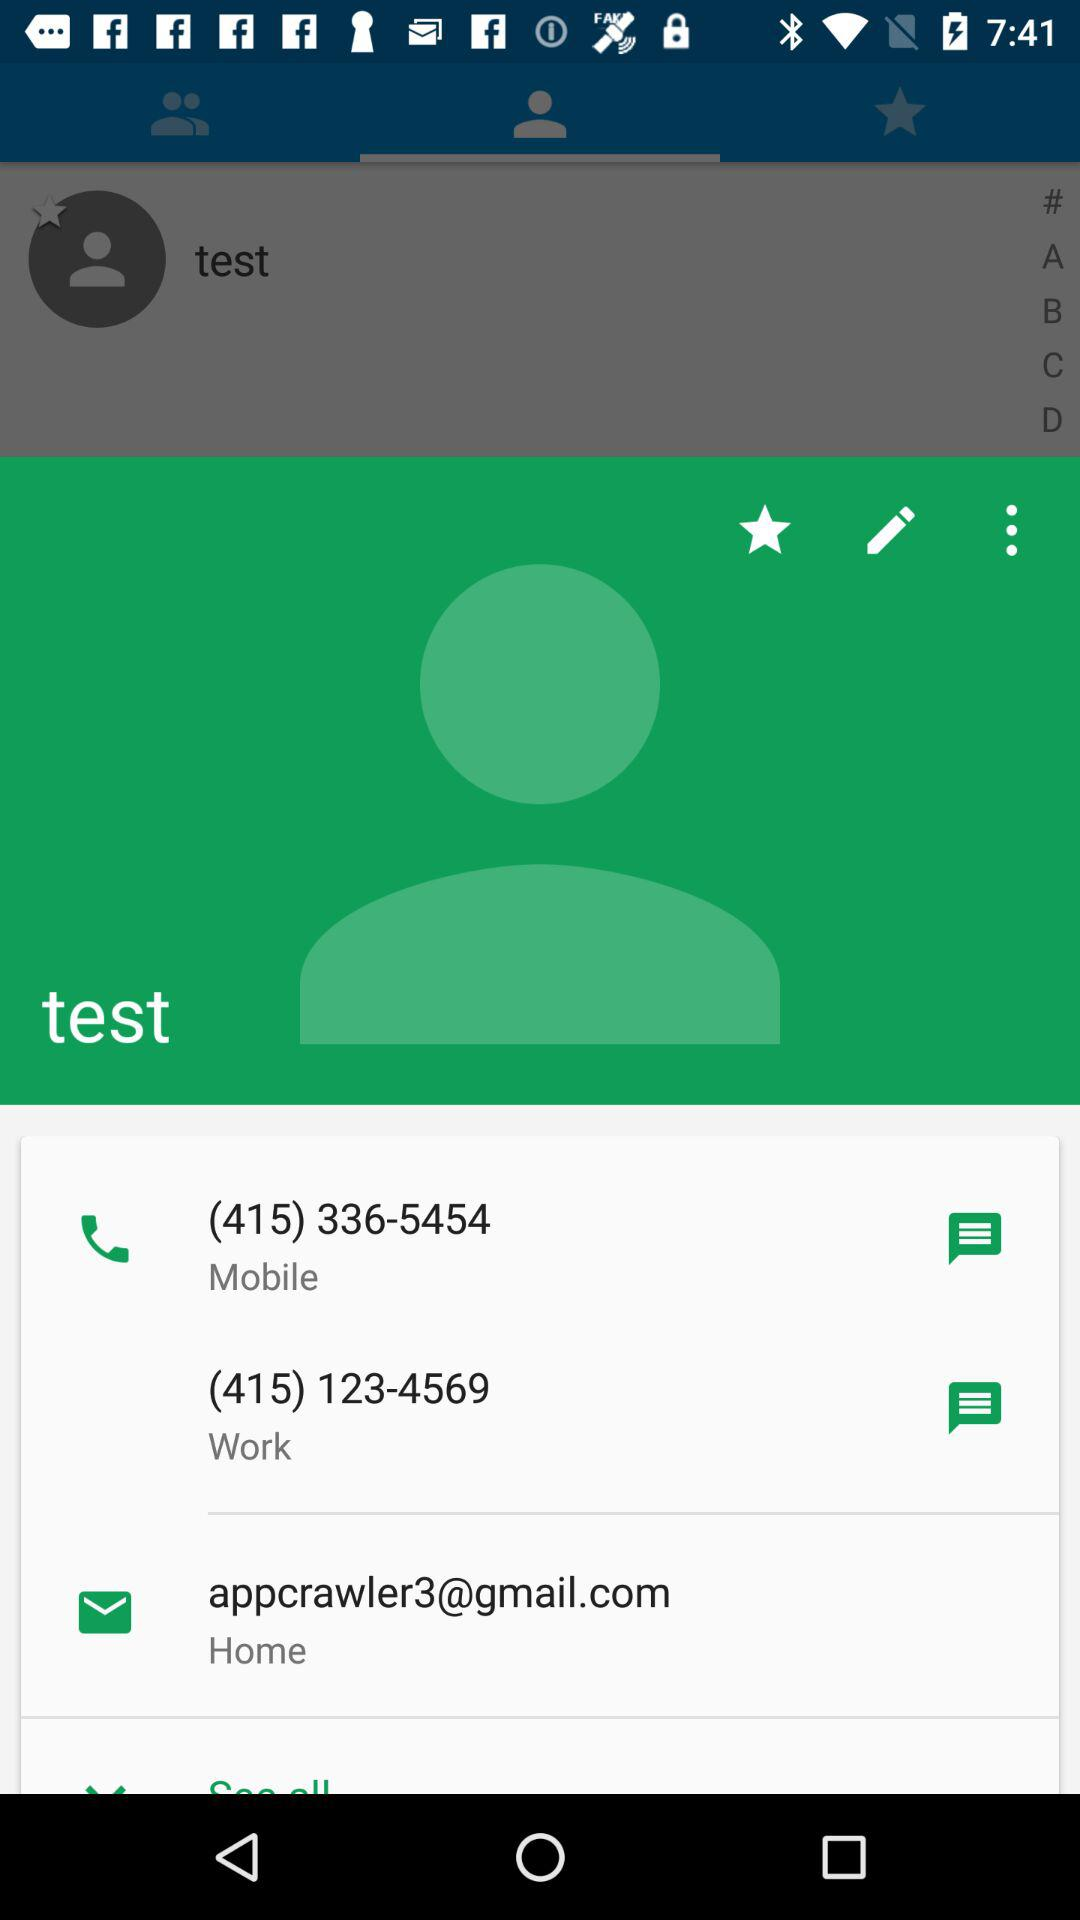What is the mobile number? The mobile numbers are (415) 336-5454 and (415) 123-4569. 